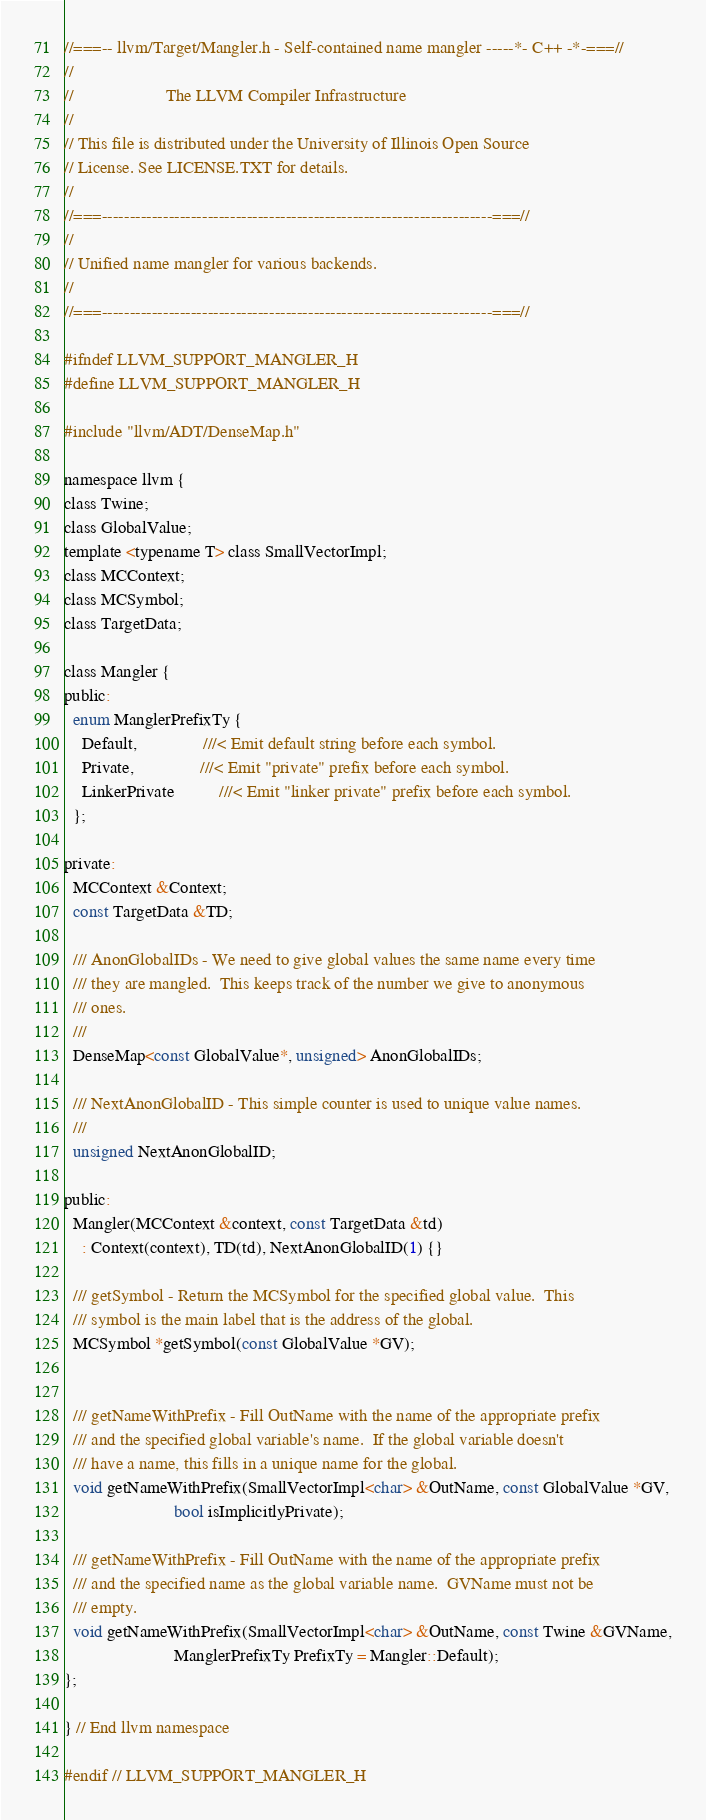Convert code to text. <code><loc_0><loc_0><loc_500><loc_500><_C_>//===-- llvm/Target/Mangler.h - Self-contained name mangler -----*- C++ -*-===//
//
//                     The LLVM Compiler Infrastructure
//
// This file is distributed under the University of Illinois Open Source
// License. See LICENSE.TXT for details.
//
//===----------------------------------------------------------------------===//
//
// Unified name mangler for various backends.
//
//===----------------------------------------------------------------------===//

#ifndef LLVM_SUPPORT_MANGLER_H
#define LLVM_SUPPORT_MANGLER_H

#include "llvm/ADT/DenseMap.h"

namespace llvm {
class Twine;
class GlobalValue;
template <typename T> class SmallVectorImpl;
class MCContext;
class MCSymbol;
class TargetData;

class Mangler {
public:
  enum ManglerPrefixTy {
    Default,               ///< Emit default string before each symbol.
    Private,               ///< Emit "private" prefix before each symbol.
    LinkerPrivate          ///< Emit "linker private" prefix before each symbol.
  };

private:
  MCContext &Context;
  const TargetData &TD;

  /// AnonGlobalIDs - We need to give global values the same name every time
  /// they are mangled.  This keeps track of the number we give to anonymous
  /// ones.
  ///
  DenseMap<const GlobalValue*, unsigned> AnonGlobalIDs;

  /// NextAnonGlobalID - This simple counter is used to unique value names.
  ///
  unsigned NextAnonGlobalID;

public:
  Mangler(MCContext &context, const TargetData &td)
    : Context(context), TD(td), NextAnonGlobalID(1) {}

  /// getSymbol - Return the MCSymbol for the specified global value.  This
  /// symbol is the main label that is the address of the global.
  MCSymbol *getSymbol(const GlobalValue *GV);

  
  /// getNameWithPrefix - Fill OutName with the name of the appropriate prefix
  /// and the specified global variable's name.  If the global variable doesn't
  /// have a name, this fills in a unique name for the global.
  void getNameWithPrefix(SmallVectorImpl<char> &OutName, const GlobalValue *GV,
                         bool isImplicitlyPrivate);
  
  /// getNameWithPrefix - Fill OutName with the name of the appropriate prefix
  /// and the specified name as the global variable name.  GVName must not be
  /// empty.
  void getNameWithPrefix(SmallVectorImpl<char> &OutName, const Twine &GVName,
                         ManglerPrefixTy PrefixTy = Mangler::Default);
};

} // End llvm namespace

#endif // LLVM_SUPPORT_MANGLER_H
</code> 